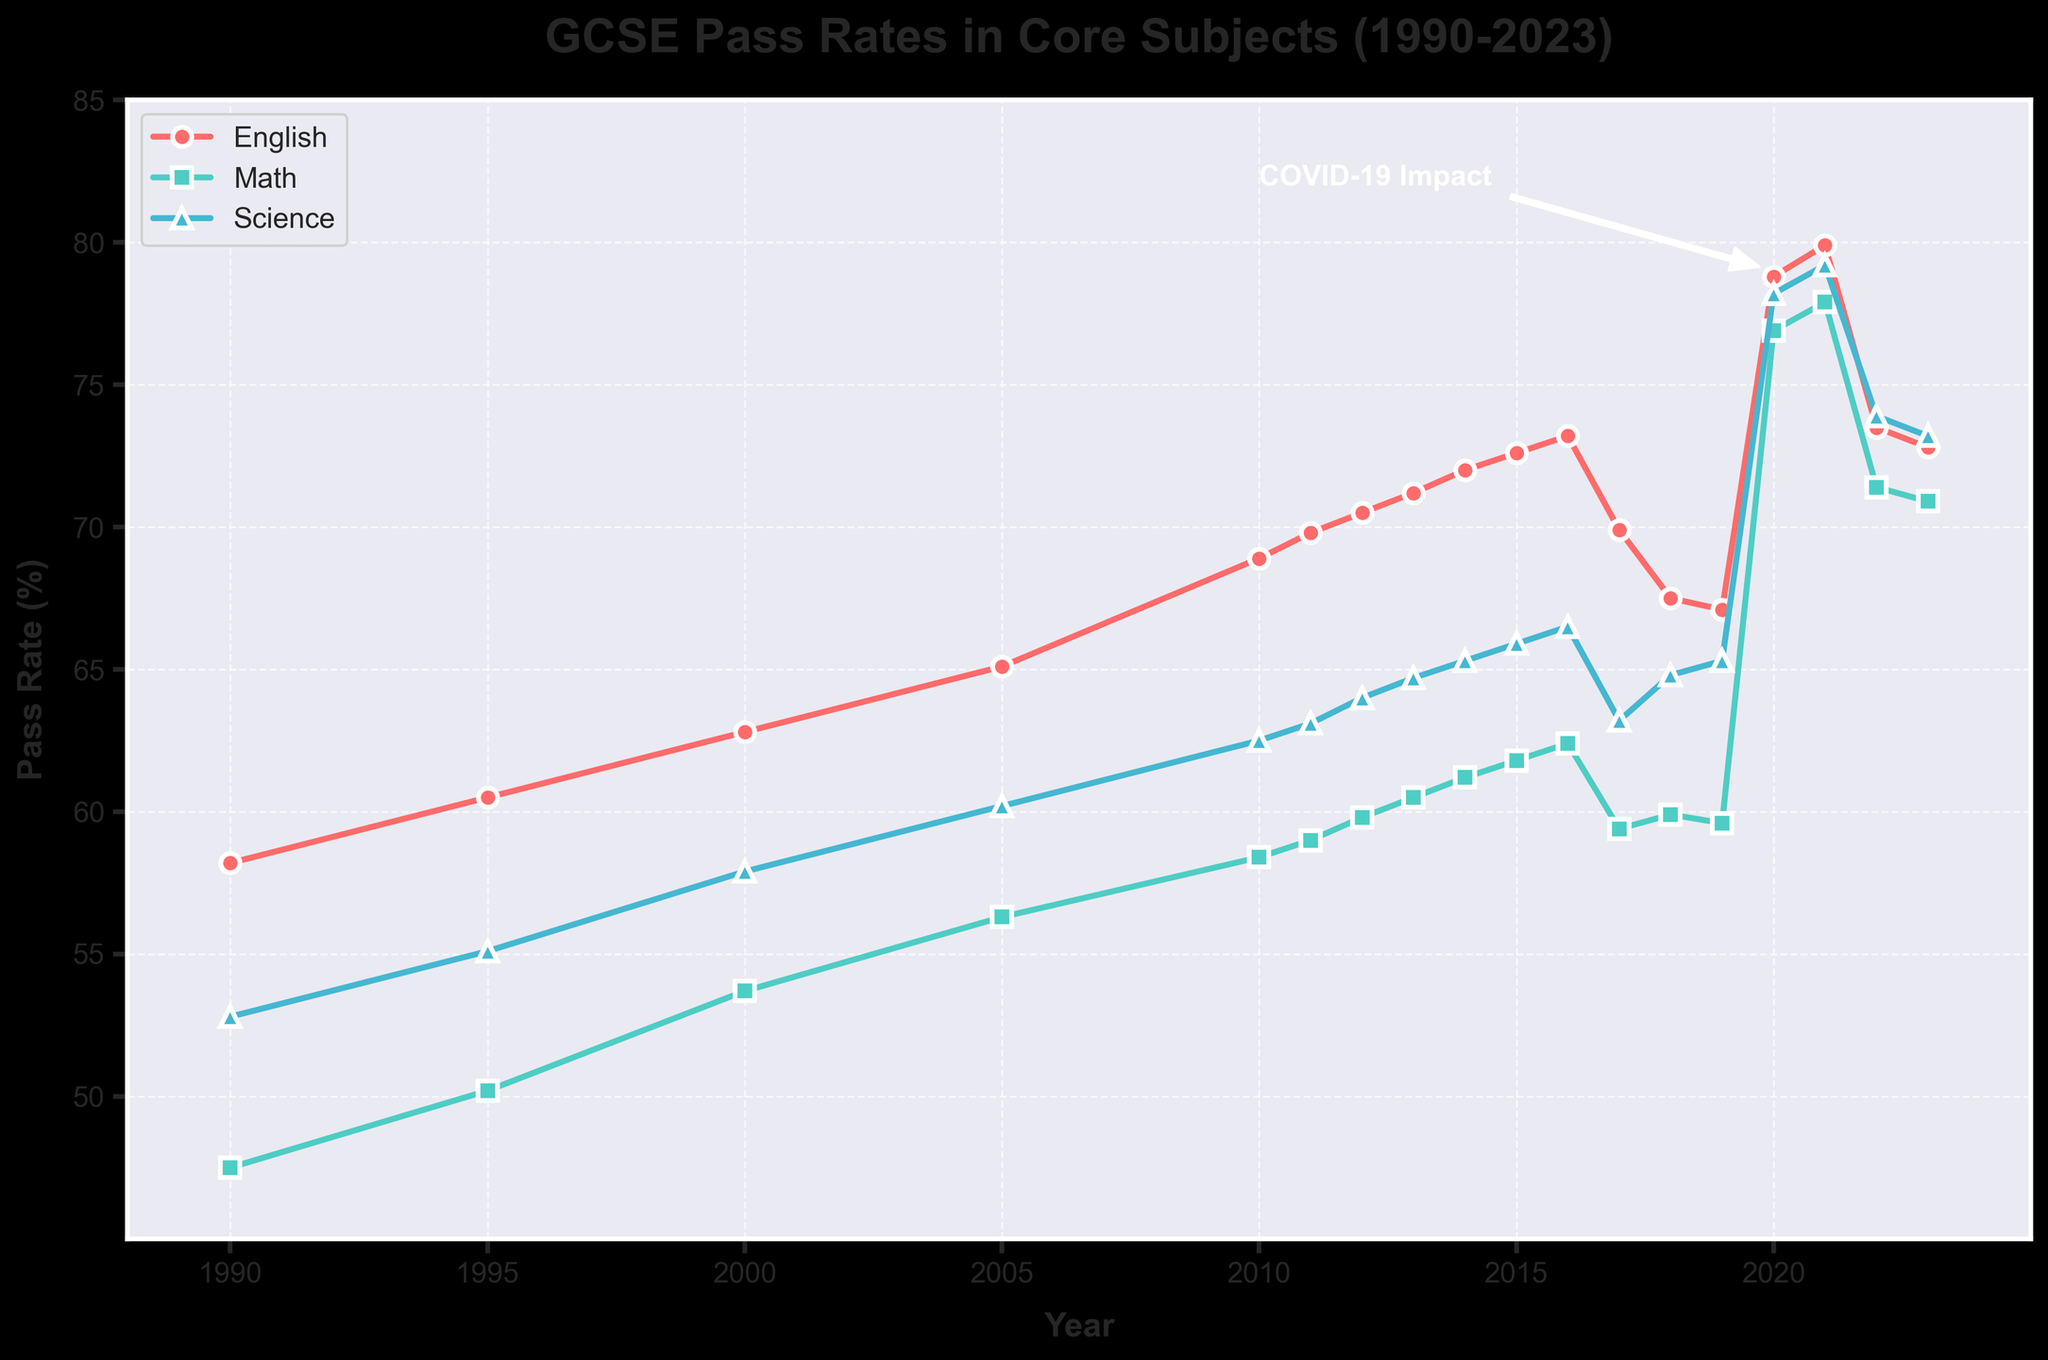What is the overall trend of GCSE pass rates in English from 1990 to 2023? The overall trend in GCSE pass rates in English shows a general increase from 1990 (58.2%) to 2023 (72.8%), despite a slight dip post-2016.
Answer: Increasing trend How did the pass rates in Science change during the COVID-19 pandemic years (2020-2021)? The pass rates in Science increased significantly during the COVID-19 years, from 65.3% in 2019 to 78.2% in 2020 and further to 79.2% in 2021.
Answer: Significant increase Which subject had the highest pass rate in the year 2013? Looking at the plot for 2013, English had a pass rate of 71.2%, Math 60.5%, and Science 64.7%. Therefore, English had the highest pass rate.
Answer: English Between which consecutive years did English see the largest drop in pass rates? The largest drop in English pass rates occurred between 2016 (73.2%) and 2017 (69.9%).
Answer: 2016-2017 Compare the pass rates of Math and Science in 2015. Which subject had a higher pass rate and by how much? In 2015, Math had a pass rate of 61.8% and Science had a pass rate of 65.9%. Science had a higher pass rate by 65.9 - 61.8 = 4.1 percentage points.
Answer: Science by 4.1% What is the average pass rate for English from 2010 to 2014? The English pass rates from 2010 to 2014 are: 68.9%, 69.8%, 70.5%, 71.2%, 72.0%. The average is (68.9 + 69.8 + 70.5 + 71.2 + 72.0) / 5 ≈ 70.48%.
Answer: 70.48% Identify the period of the most notable simultaneous increase in pass rates for all three subjects. The most notable simultaneous increase occurred during the COVID-19 pandemic years, between 2019 and 2021, where all three subjects witnessed a significant rise.
Answer: 2019-2021 Compare the trends in pass rates between English and Math from 1990 to 2010. Both subjects show an increasing trend; however, English consistently has higher pass rates than Math throughout this period.
Answer: Both increased, English consistently higher Visually, what is the steepest section in the Science pass rate line? The steepest section in the Science pass rate line is during the years 2019 to 2020, where the line sharply rises due to the COVID-19 impact.
Answer: 2019-2020 